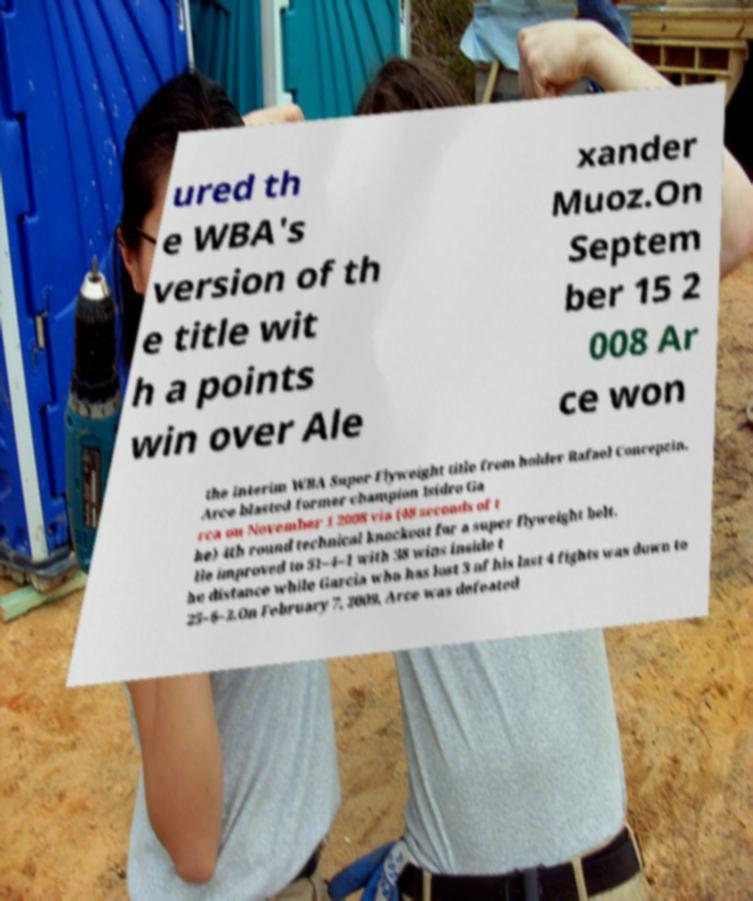Could you extract and type out the text from this image? ured th e WBA's version of th e title wit h a points win over Ale xander Muoz.On Septem ber 15 2 008 Ar ce won the Interim WBA Super Flyweight title from holder Rafael Concepcin. Arce blasted former champion Isidro Ga rca on November 1 2008 via (48 seconds of t he) 4th round technical knockout for a super flyweight belt. He improved to 51–4–1 with 38 wins inside t he distance while Garcia who has lost 3 of his last 4 fights was down to 25–6–2.On February 7, 2009, Arce was defeated 